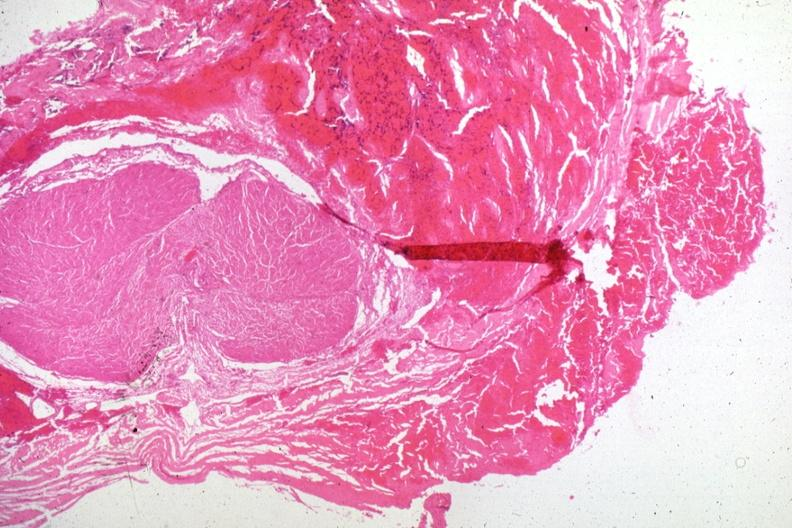what is present?
Answer the question using a single word or phrase. Endocrine 